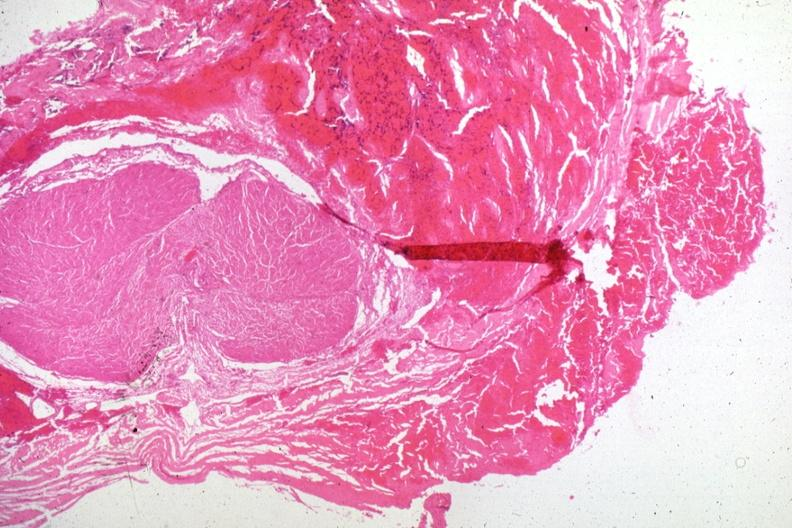what is present?
Answer the question using a single word or phrase. Endocrine 